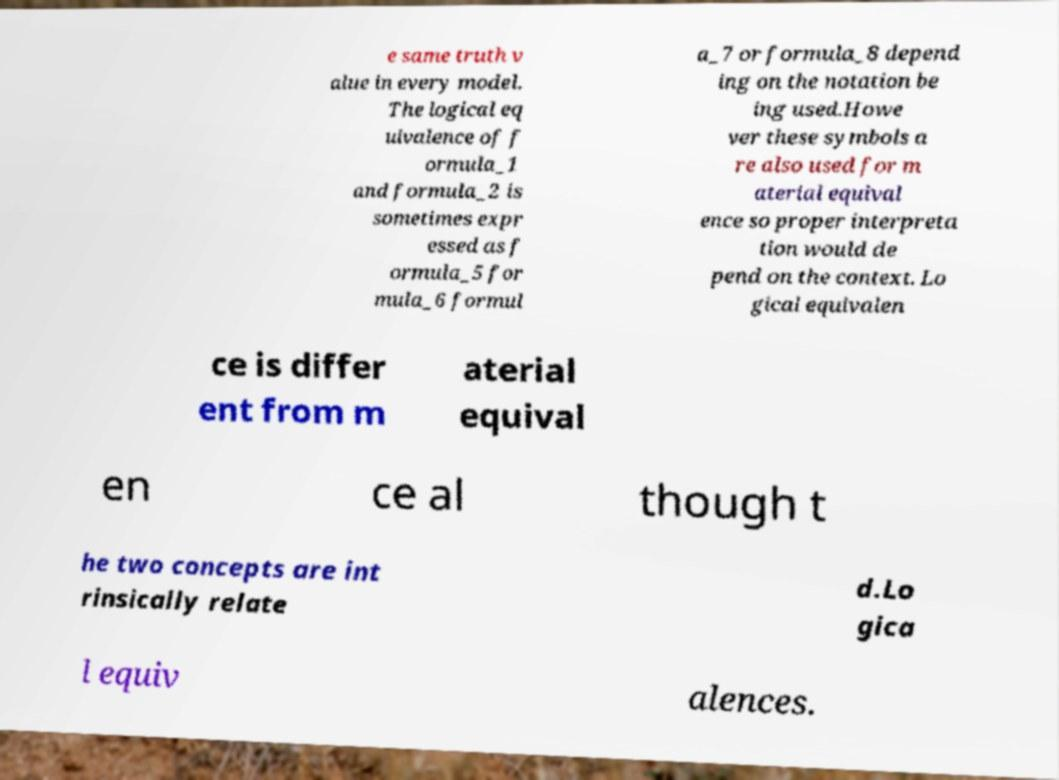Could you extract and type out the text from this image? e same truth v alue in every model. The logical eq uivalence of f ormula_1 and formula_2 is sometimes expr essed as f ormula_5 for mula_6 formul a_7 or formula_8 depend ing on the notation be ing used.Howe ver these symbols a re also used for m aterial equival ence so proper interpreta tion would de pend on the context. Lo gical equivalen ce is differ ent from m aterial equival en ce al though t he two concepts are int rinsically relate d.Lo gica l equiv alences. 